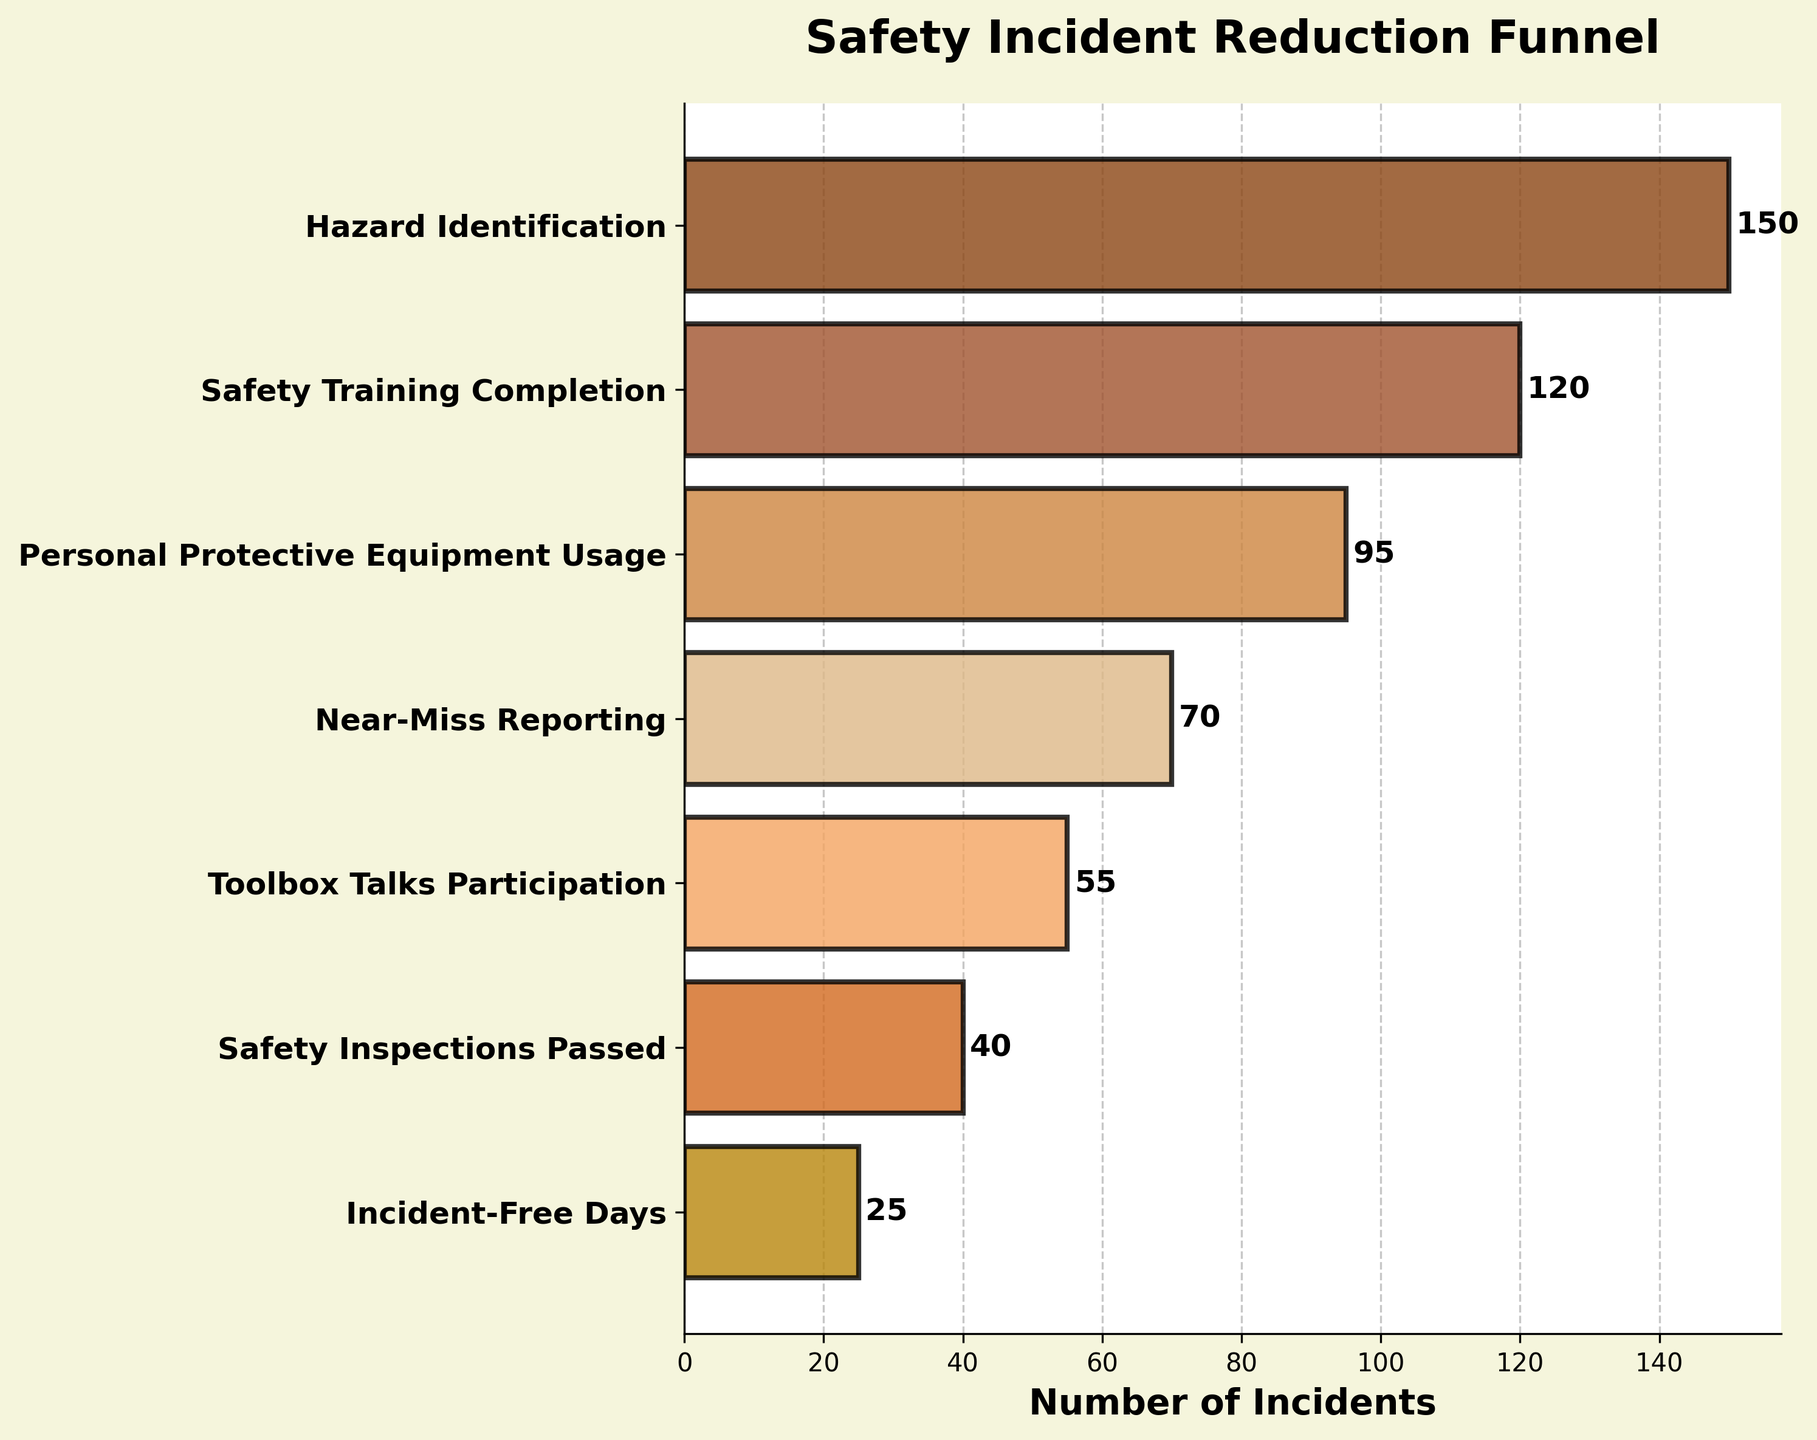What's the title of the plot? The title is located at the top of the plot.
Answer: Safety Incident Reduction Funnel How many stages are represented in the funnel? The stages are listed along the vertical axis. By counting the number of labels, we can determine the quantity.
Answer: 7 Which stage has the highest number of incidents? The longest horizontal bar, which represents the highest value, correlates with the stage at the same y-axis position.
Answer: Hazard Identification What is the difference in the number of incidents between the stages "Hazard Identification" and "Near-Miss Reporting"? Identify the numerical values for both stages, then subtract the smaller from the larger: 150 (Hazard Identification) - 70 (Near-Miss Reporting).
Answer: 80 What is the average number of incidents across all stages? Sum the numbers of incidents and divide by the number of stages: (150 + 120 + 95 + 70 + 55 + 40 + 25) / 7.
Answer: 79.29 Which stages have fewer than 50 incidents? Compare the values of each stage to 50: Personal Protective Equipment Usage (95), Near-Miss Reporting (70), Toolbox Talks Participation (55), Safety Inspections Passed (40), and Incident-Free Days (25). The stages with fewer than 50 are "Safety Inspections Passed" and "Incident-Free Days".
Answer: Safety Inspections Passed; Incident-Free Days What color is used for the "Toolbox Talks Participation" stage? Locate the corresponding bar color in the plot.
Answer: #F4A460 (sandy brown) What percentage of incidents were reduced after "Personal Protective Equipment Usage"? Calculate the percentage reduction: ((95 - 70) / 95) * 100%.
Answer: 26.32% Which two stages have the smallest reduction in incidents between them? Compute the differences between adjacent stages and compare them. The smallest reduction (difference) is between "Safety Inspections Passed" (40) and "Incident-Free Days" (25): 40 - 25.
Answer: Safety Inspections Passed to Incident-Free Days 